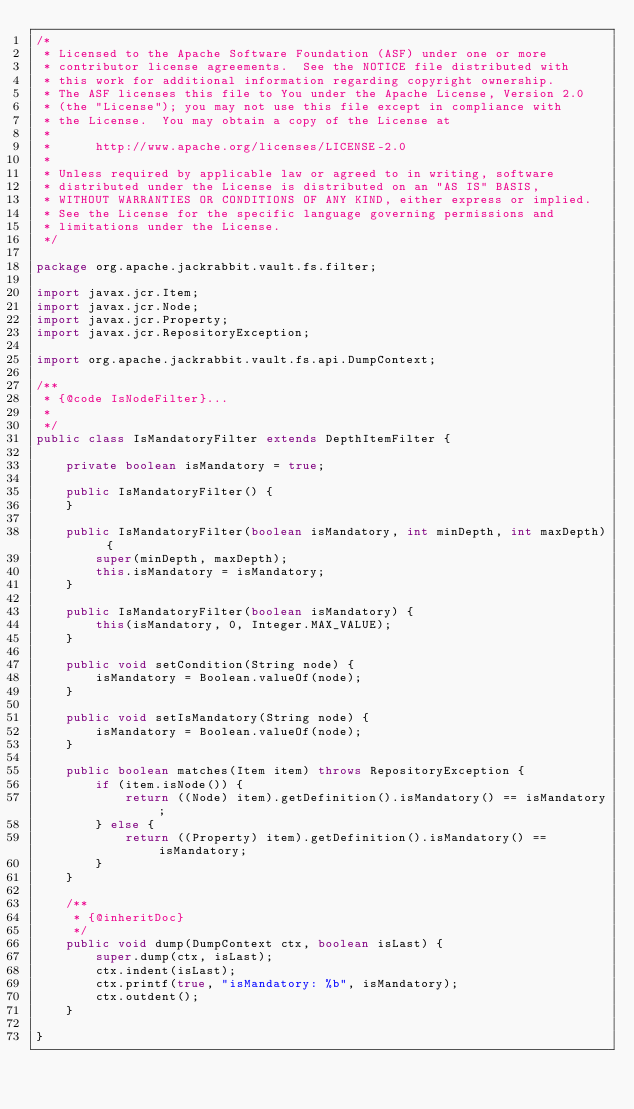<code> <loc_0><loc_0><loc_500><loc_500><_Java_>/*
 * Licensed to the Apache Software Foundation (ASF) under one or more
 * contributor license agreements.  See the NOTICE file distributed with
 * this work for additional information regarding copyright ownership.
 * The ASF licenses this file to You under the Apache License, Version 2.0
 * (the "License"); you may not use this file except in compliance with
 * the License.  You may obtain a copy of the License at
 *
 *      http://www.apache.org/licenses/LICENSE-2.0
 *
 * Unless required by applicable law or agreed to in writing, software
 * distributed under the License is distributed on an "AS IS" BASIS,
 * WITHOUT WARRANTIES OR CONDITIONS OF ANY KIND, either express or implied.
 * See the License for the specific language governing permissions and
 * limitations under the License.
 */

package org.apache.jackrabbit.vault.fs.filter;

import javax.jcr.Item;
import javax.jcr.Node;
import javax.jcr.Property;
import javax.jcr.RepositoryException;

import org.apache.jackrabbit.vault.fs.api.DumpContext;

/**
 * {@code IsNodeFilter}...
 *
 */
public class IsMandatoryFilter extends DepthItemFilter {

    private boolean isMandatory = true;

    public IsMandatoryFilter() {
    }

    public IsMandatoryFilter(boolean isMandatory, int minDepth, int maxDepth) {
        super(minDepth, maxDepth);
        this.isMandatory = isMandatory;
    }

    public IsMandatoryFilter(boolean isMandatory) {
        this(isMandatory, 0, Integer.MAX_VALUE);
    }

    public void setCondition(String node) {
        isMandatory = Boolean.valueOf(node);
    }

    public void setIsMandatory(String node) {
        isMandatory = Boolean.valueOf(node);
    }

    public boolean matches(Item item) throws RepositoryException {
        if (item.isNode()) {
            return ((Node) item).getDefinition().isMandatory() == isMandatory;
        } else {
            return ((Property) item).getDefinition().isMandatory() == isMandatory;
        }
    }

    /**
     * {@inheritDoc}
     */
    public void dump(DumpContext ctx, boolean isLast) {
        super.dump(ctx, isLast);
        ctx.indent(isLast);
        ctx.printf(true, "isMandatory: %b", isMandatory);
        ctx.outdent();
    }
    
}</code> 